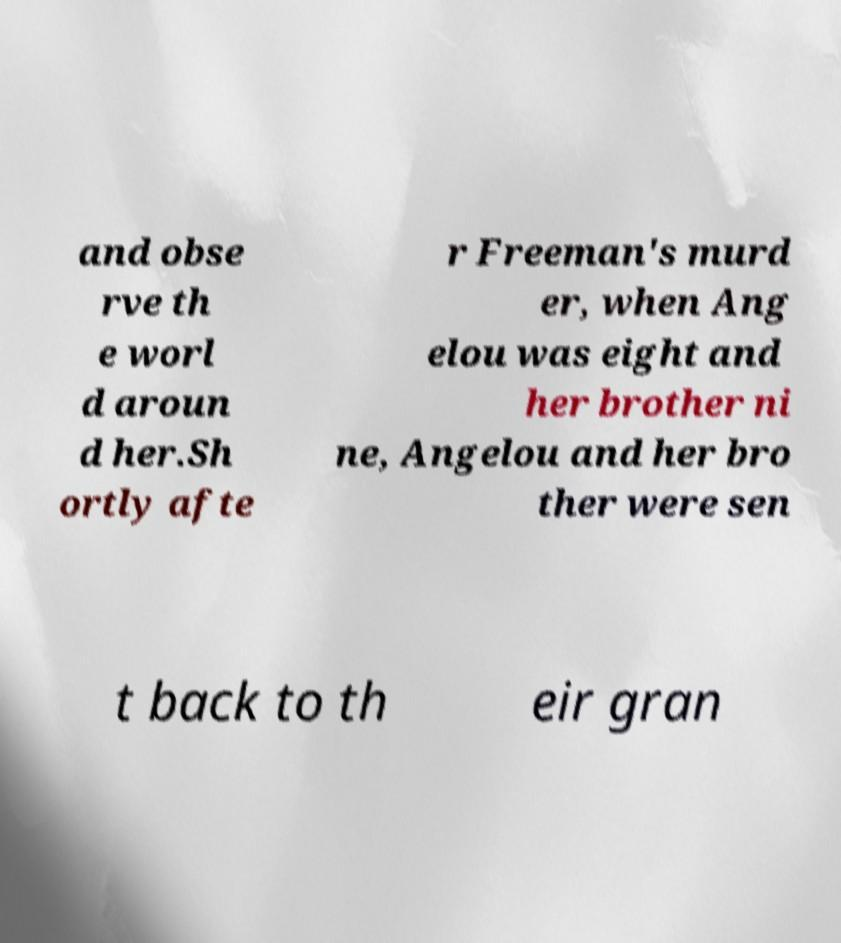Could you extract and type out the text from this image? and obse rve th e worl d aroun d her.Sh ortly afte r Freeman's murd er, when Ang elou was eight and her brother ni ne, Angelou and her bro ther were sen t back to th eir gran 